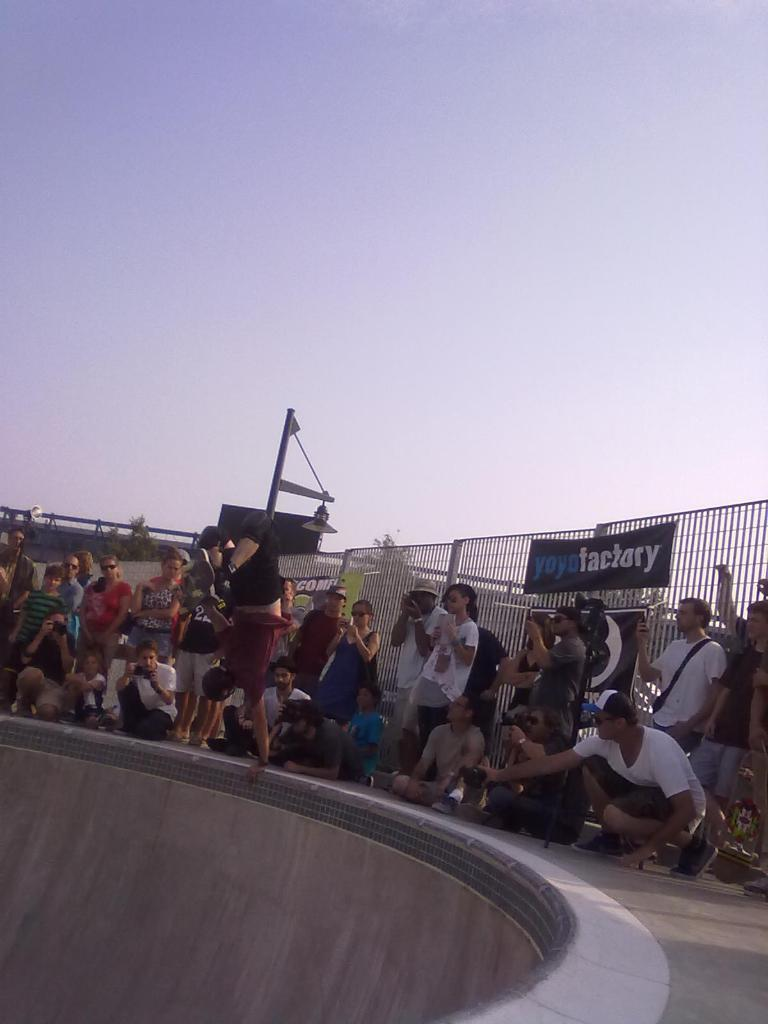What is the main subject of the image? There is a group of people in the image. Can you describe the background of the image? There is railing visible in the background of the image. What is the color of the sky in the image? The sky is blue and white in color. Where is the ball being played by the dad in the image? There is no ball or dad present in the image. What type of hydrant can be seen near the group of people in the image? There is no hydrant visible in the image. 